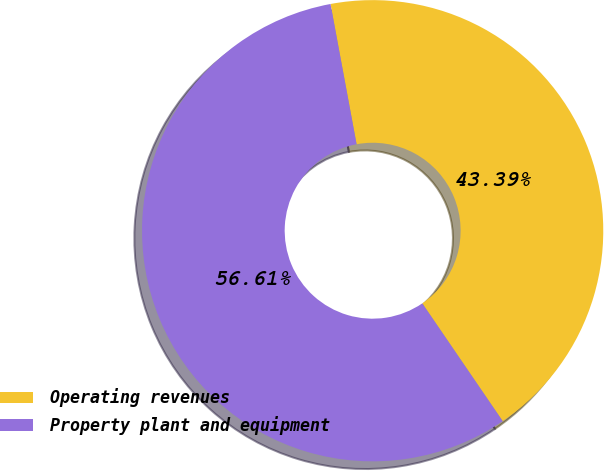Convert chart. <chart><loc_0><loc_0><loc_500><loc_500><pie_chart><fcel>Operating revenues<fcel>Property plant and equipment<nl><fcel>43.39%<fcel>56.61%<nl></chart> 